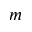<formula> <loc_0><loc_0><loc_500><loc_500>m</formula> 